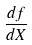<formula> <loc_0><loc_0><loc_500><loc_500>\frac { d f } { d X }</formula> 